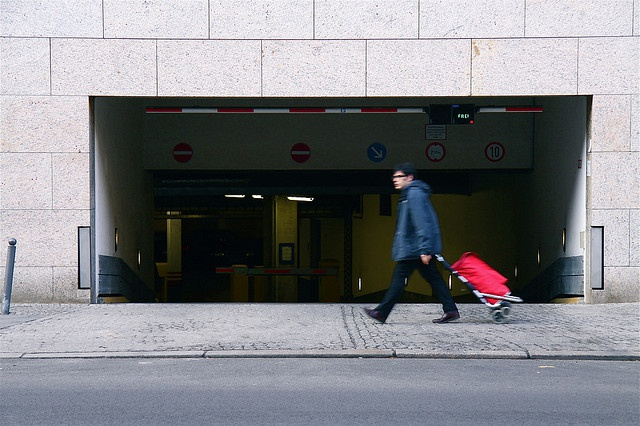Describe the objects in this image and their specific colors. I can see people in white, black, blue, navy, and gray tones and suitcase in white, salmon, and brown tones in this image. 